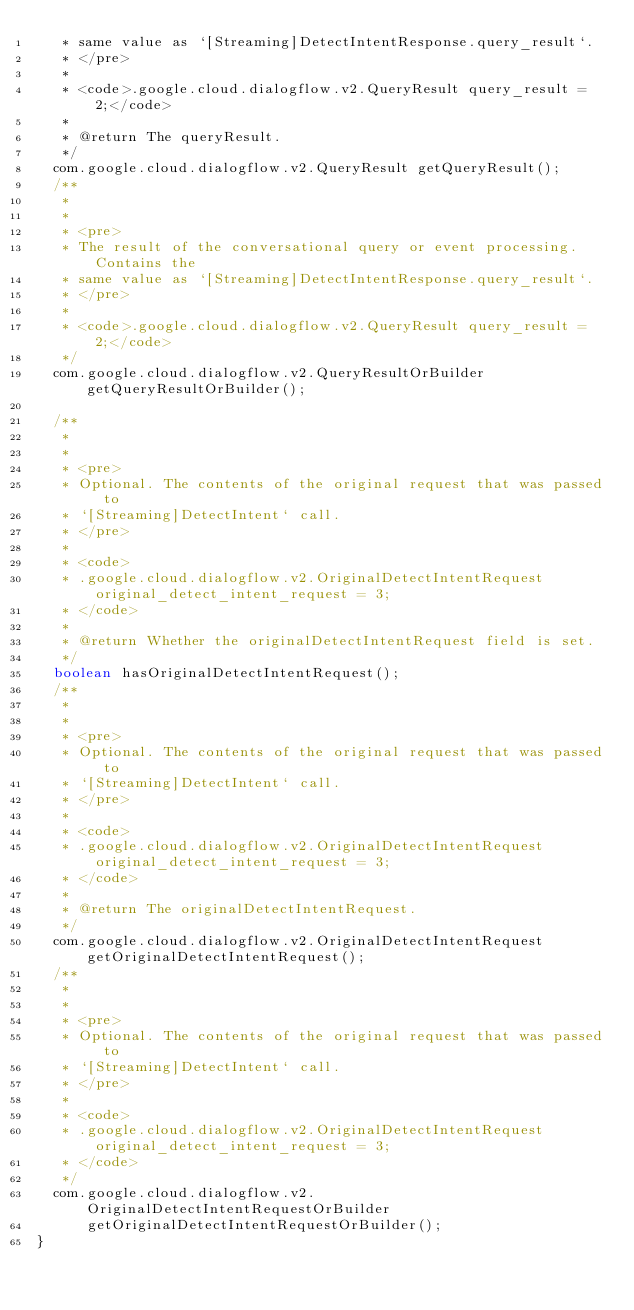Convert code to text. <code><loc_0><loc_0><loc_500><loc_500><_Java_>   * same value as `[Streaming]DetectIntentResponse.query_result`.
   * </pre>
   *
   * <code>.google.cloud.dialogflow.v2.QueryResult query_result = 2;</code>
   *
   * @return The queryResult.
   */
  com.google.cloud.dialogflow.v2.QueryResult getQueryResult();
  /**
   *
   *
   * <pre>
   * The result of the conversational query or event processing. Contains the
   * same value as `[Streaming]DetectIntentResponse.query_result`.
   * </pre>
   *
   * <code>.google.cloud.dialogflow.v2.QueryResult query_result = 2;</code>
   */
  com.google.cloud.dialogflow.v2.QueryResultOrBuilder getQueryResultOrBuilder();

  /**
   *
   *
   * <pre>
   * Optional. The contents of the original request that was passed to
   * `[Streaming]DetectIntent` call.
   * </pre>
   *
   * <code>
   * .google.cloud.dialogflow.v2.OriginalDetectIntentRequest original_detect_intent_request = 3;
   * </code>
   *
   * @return Whether the originalDetectIntentRequest field is set.
   */
  boolean hasOriginalDetectIntentRequest();
  /**
   *
   *
   * <pre>
   * Optional. The contents of the original request that was passed to
   * `[Streaming]DetectIntent` call.
   * </pre>
   *
   * <code>
   * .google.cloud.dialogflow.v2.OriginalDetectIntentRequest original_detect_intent_request = 3;
   * </code>
   *
   * @return The originalDetectIntentRequest.
   */
  com.google.cloud.dialogflow.v2.OriginalDetectIntentRequest getOriginalDetectIntentRequest();
  /**
   *
   *
   * <pre>
   * Optional. The contents of the original request that was passed to
   * `[Streaming]DetectIntent` call.
   * </pre>
   *
   * <code>
   * .google.cloud.dialogflow.v2.OriginalDetectIntentRequest original_detect_intent_request = 3;
   * </code>
   */
  com.google.cloud.dialogflow.v2.OriginalDetectIntentRequestOrBuilder
      getOriginalDetectIntentRequestOrBuilder();
}
</code> 